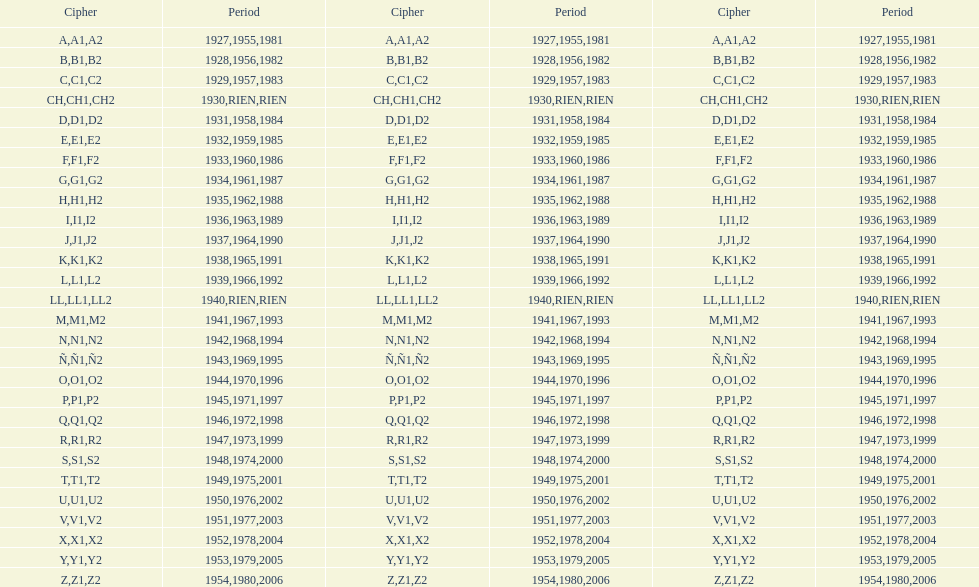Other than 1927 what year did the code start with a? 1955, 1981. 